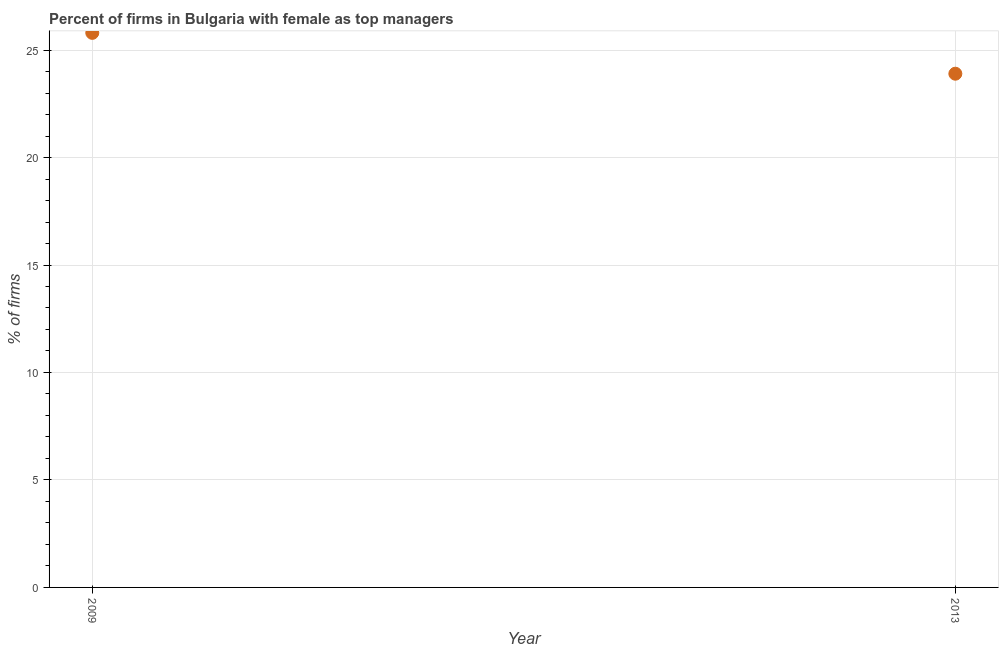What is the percentage of firms with female as top manager in 2009?
Provide a short and direct response. 25.8. Across all years, what is the maximum percentage of firms with female as top manager?
Provide a short and direct response. 25.8. Across all years, what is the minimum percentage of firms with female as top manager?
Your answer should be very brief. 23.9. In which year was the percentage of firms with female as top manager maximum?
Provide a succinct answer. 2009. What is the sum of the percentage of firms with female as top manager?
Your response must be concise. 49.7. What is the difference between the percentage of firms with female as top manager in 2009 and 2013?
Offer a terse response. 1.9. What is the average percentage of firms with female as top manager per year?
Keep it short and to the point. 24.85. What is the median percentage of firms with female as top manager?
Keep it short and to the point. 24.85. In how many years, is the percentage of firms with female as top manager greater than 9 %?
Ensure brevity in your answer.  2. What is the ratio of the percentage of firms with female as top manager in 2009 to that in 2013?
Give a very brief answer. 1.08. Is the percentage of firms with female as top manager in 2009 less than that in 2013?
Give a very brief answer. No. In how many years, is the percentage of firms with female as top manager greater than the average percentage of firms with female as top manager taken over all years?
Keep it short and to the point. 1. Does the percentage of firms with female as top manager monotonically increase over the years?
Ensure brevity in your answer.  No. What is the difference between two consecutive major ticks on the Y-axis?
Provide a succinct answer. 5. Are the values on the major ticks of Y-axis written in scientific E-notation?
Offer a very short reply. No. Does the graph contain any zero values?
Provide a succinct answer. No. Does the graph contain grids?
Ensure brevity in your answer.  Yes. What is the title of the graph?
Offer a terse response. Percent of firms in Bulgaria with female as top managers. What is the label or title of the X-axis?
Ensure brevity in your answer.  Year. What is the label or title of the Y-axis?
Provide a succinct answer. % of firms. What is the % of firms in 2009?
Make the answer very short. 25.8. What is the % of firms in 2013?
Offer a terse response. 23.9. What is the ratio of the % of firms in 2009 to that in 2013?
Keep it short and to the point. 1.08. 